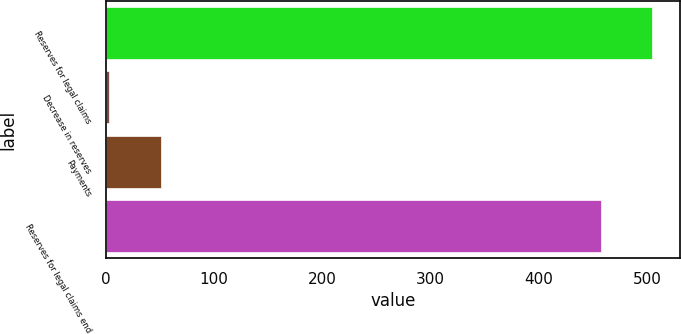Convert chart. <chart><loc_0><loc_0><loc_500><loc_500><bar_chart><fcel>Reserves for legal claims<fcel>Decrease in reserves<fcel>Payments<fcel>Reserves for legal claims end<nl><fcel>504.8<fcel>3<fcel>50.9<fcel>456.9<nl></chart> 